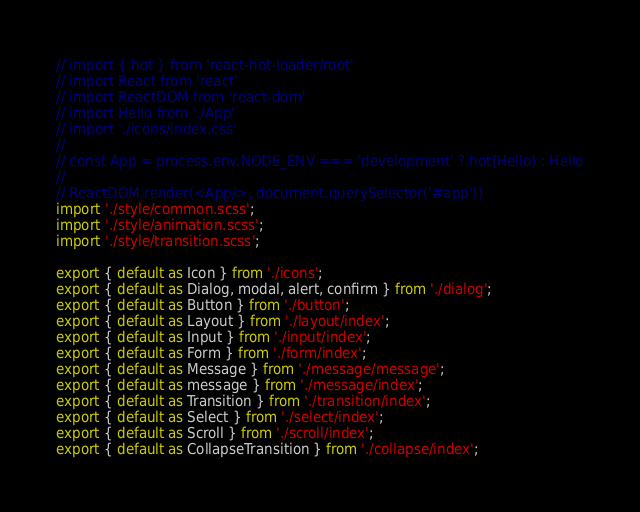Convert code to text. <code><loc_0><loc_0><loc_500><loc_500><_TypeScript_>// import { hot } from 'react-hot-loader/root'
// import React from 'react'
// import ReactDOM from 'react-dom'
// import Hello from './App'
// import './icons/index.css'
//
// const App = process.env.NODE_ENV === 'development' ? hot(Hello) : Hello
//
// ReactDOM.render(<App/>, document.querySelector('#app'))
import './style/common.scss';
import './style/animation.scss';
import './style/transition.scss';

export { default as Icon } from './icons';
export { default as Dialog, modal, alert, confirm } from './dialog';
export { default as Button } from './button';
export { default as Layout } from './layout/index';
export { default as Input } from './input/index';
export { default as Form } from './form/index';
export { default as Message } from './message/message';
export { default as message } from './message/index';
export { default as Transition } from './transition/index';
export { default as Select } from './select/index';
export { default as Scroll } from './scroll/index';
export { default as CollapseTransition } from './collapse/index';
</code> 